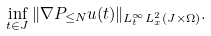Convert formula to latex. <formula><loc_0><loc_0><loc_500><loc_500>\inf _ { t \in J } \| \nabla P _ { \leq N } u ( t ) \| _ { L _ { t } ^ { \infty } L _ { x } ^ { 2 } ( J \times \Omega ) } .</formula> 